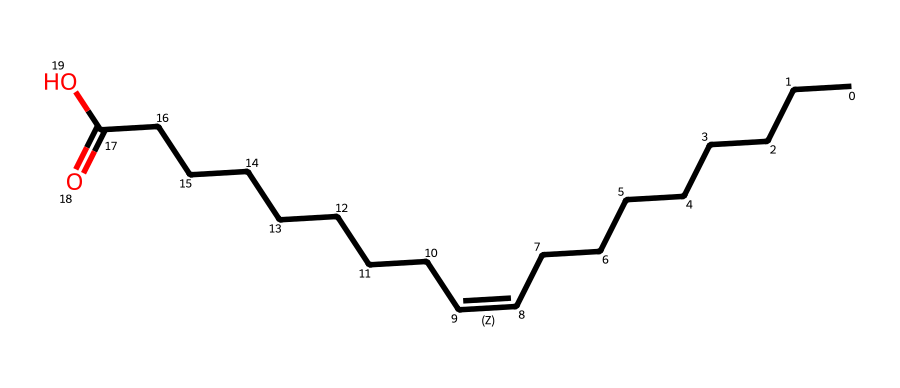What is the common name for this chemical? This chemical is known as oleic acid, which is derived from its structure containing a long hydrocarbon chain with a carboxylic acid functional group. The recognition of the structure allows us to easily associate it with its common name.
Answer: oleic acid How many carbon atoms are present in oleic acid? By analyzing the SMILES representation, we can count the total number of carbon atoms: there are 18 carbon atoms in the long hydrocarbon chain and the carboxylic acid group.
Answer: 18 What type of isomerism does oleic acid exhibit? Oleic acid exhibits geometric isomerism due to the presence of a carbon-carbon double bond (C=C) in its structure, which allows for the configuration of cis and trans isomers.
Answer: geometric isomerism What is the configuration around the double bond in cis oleic acid? In cis oleic acid, the two hydrogen atoms attached to the carbon atoms involved in the double bond are on the same side, leading to the cis configuration being identified.
Answer: same side How does the presence of cis double bond affect the properties of oleic acid? The cis configuration introduces a kink in the fatty acid chain, which creates a lower melting point and a liquid state at room temperature, thus affecting its physical properties.
Answer: lower melting point Which functional group is present in oleic acid? The functional group present in oleic acid is the carboxylic acid group (-COOH), as seen in the structure where the molecule ends with the carbon double-bonded to an oxygen and single-bonded to a hydroxyl (OH).
Answer: carboxylic acid 